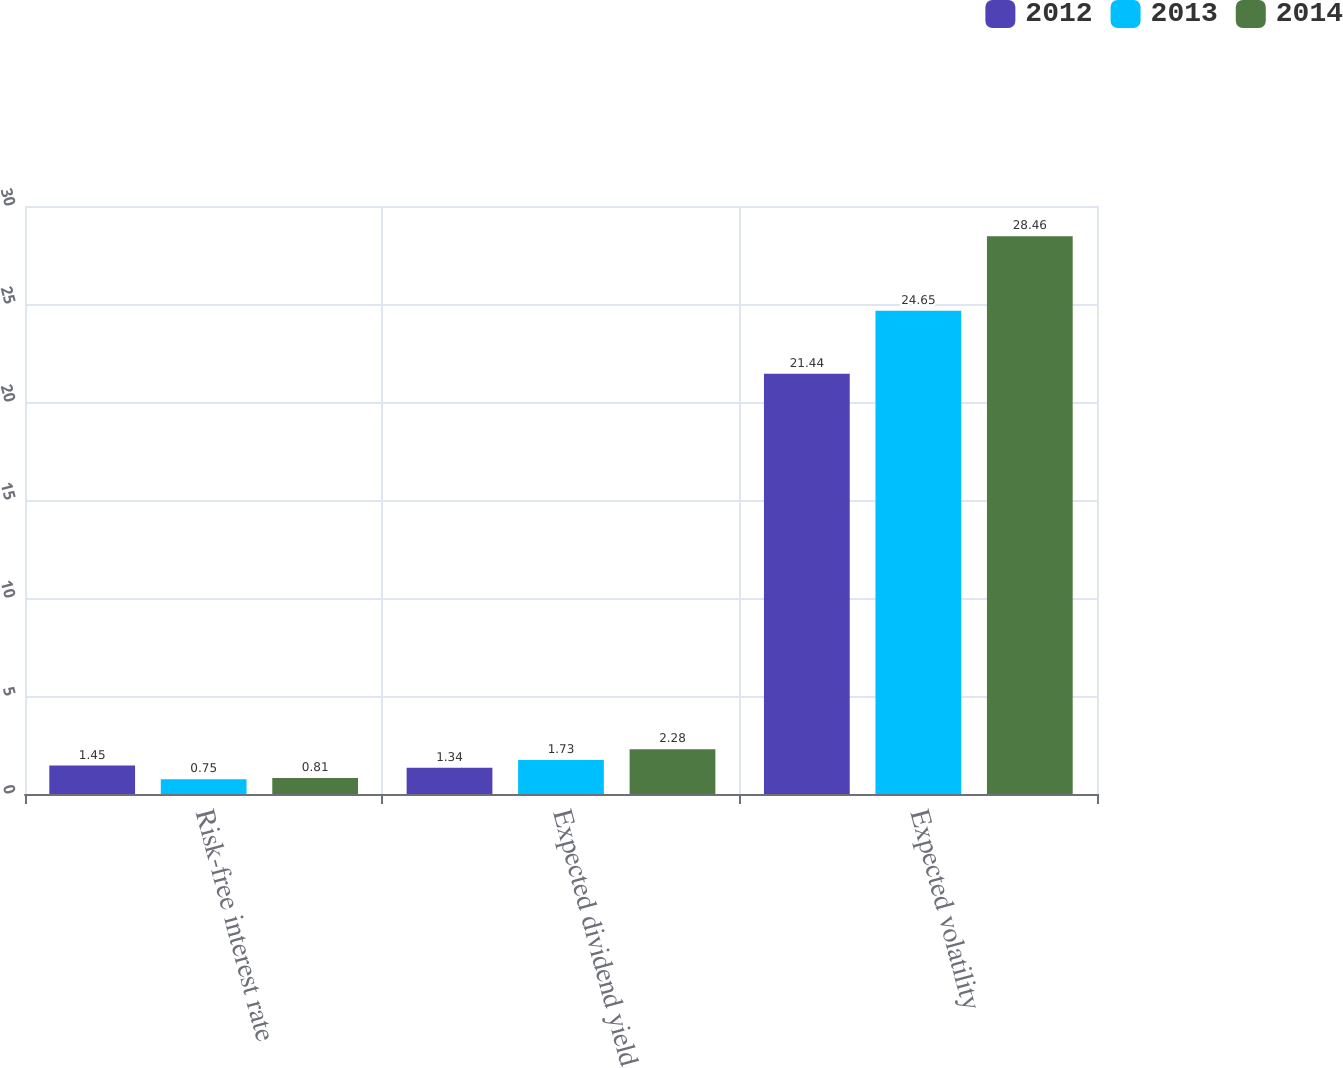<chart> <loc_0><loc_0><loc_500><loc_500><stacked_bar_chart><ecel><fcel>Risk-free interest rate<fcel>Expected dividend yield<fcel>Expected volatility<nl><fcel>2012<fcel>1.45<fcel>1.34<fcel>21.44<nl><fcel>2013<fcel>0.75<fcel>1.73<fcel>24.65<nl><fcel>2014<fcel>0.81<fcel>2.28<fcel>28.46<nl></chart> 